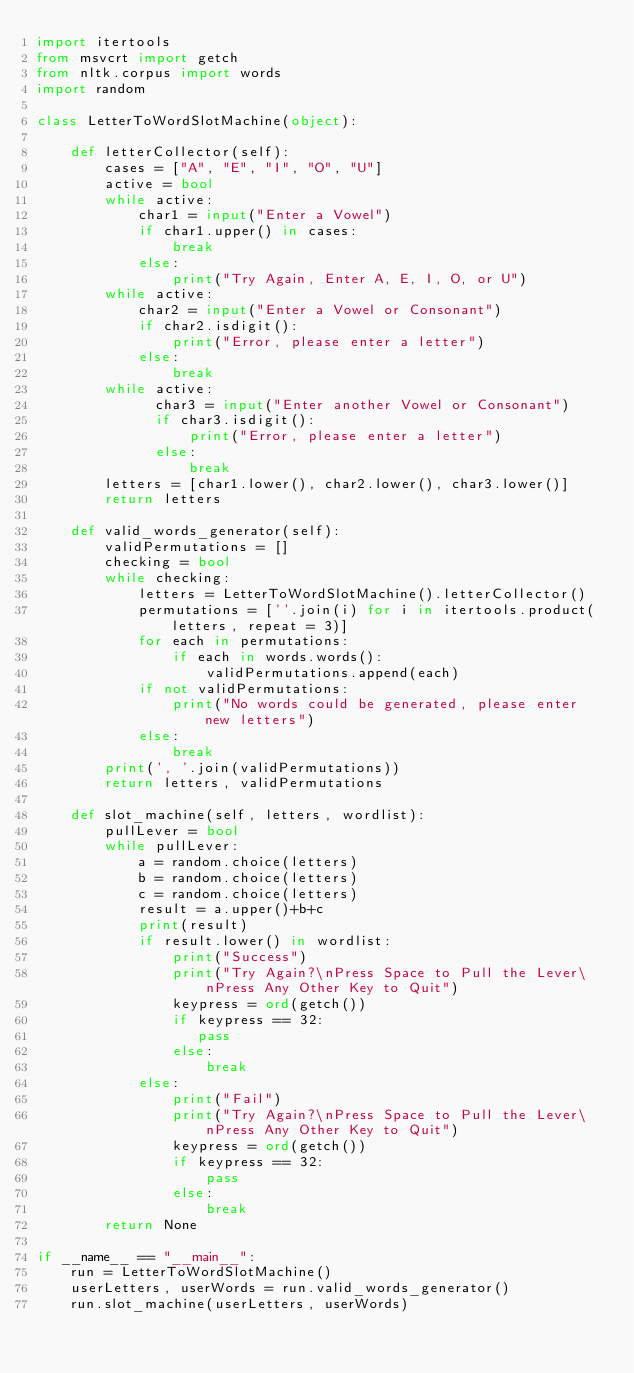<code> <loc_0><loc_0><loc_500><loc_500><_Python_>import itertools
from msvcrt import getch
from nltk.corpus import words
import random

class LetterToWordSlotMachine(object):

    def letterCollector(self):
        cases = ["A", "E", "I", "O", "U"]
        active = bool
        while active:
            char1 = input("Enter a Vowel")
            if char1.upper() in cases:
                break
            else:
                print("Try Again, Enter A, E, I, O, or U")
        while active:
            char2 = input("Enter a Vowel or Consonant")
            if char2.isdigit():
                print("Error, please enter a letter")
            else:
                break
        while active:
              char3 = input("Enter another Vowel or Consonant")
              if char3.isdigit():
                  print("Error, please enter a letter")
              else:
                  break
        letters = [char1.lower(), char2.lower(), char3.lower()]
        return letters

    def valid_words_generator(self):
        validPermutations = []
        checking = bool
        while checking:
            letters = LetterToWordSlotMachine().letterCollector()
            permutations = [''.join(i) for i in itertools.product(letters, repeat = 3)]
            for each in permutations:
                if each in words.words():
                    validPermutations.append(each)
            if not validPermutations:
                print("No words could be generated, please enter new letters")
            else:
                break
        print(', '.join(validPermutations))
        return letters, validPermutations

    def slot_machine(self, letters, wordlist):
        pullLever = bool
        while pullLever:
            a = random.choice(letters)
            b = random.choice(letters)
            c = random.choice(letters)
            result = a.upper()+b+c
            print(result)
            if result.lower() in wordlist:
                print("Success")
                print("Try Again?\nPress Space to Pull the Lever\nPress Any Other Key to Quit")
                keypress = ord(getch())
                if keypress == 32:
                   pass
                else:
                    break
            else:
                print("Fail")
                print("Try Again?\nPress Space to Pull the Lever\nPress Any Other Key to Quit")
                keypress = ord(getch())
                if keypress == 32:
                    pass
                else:
                    break
        return None

if __name__ == "__main__":
    run = LetterToWordSlotMachine()
    userLetters, userWords = run.valid_words_generator()
    run.slot_machine(userLetters, userWords)
</code> 